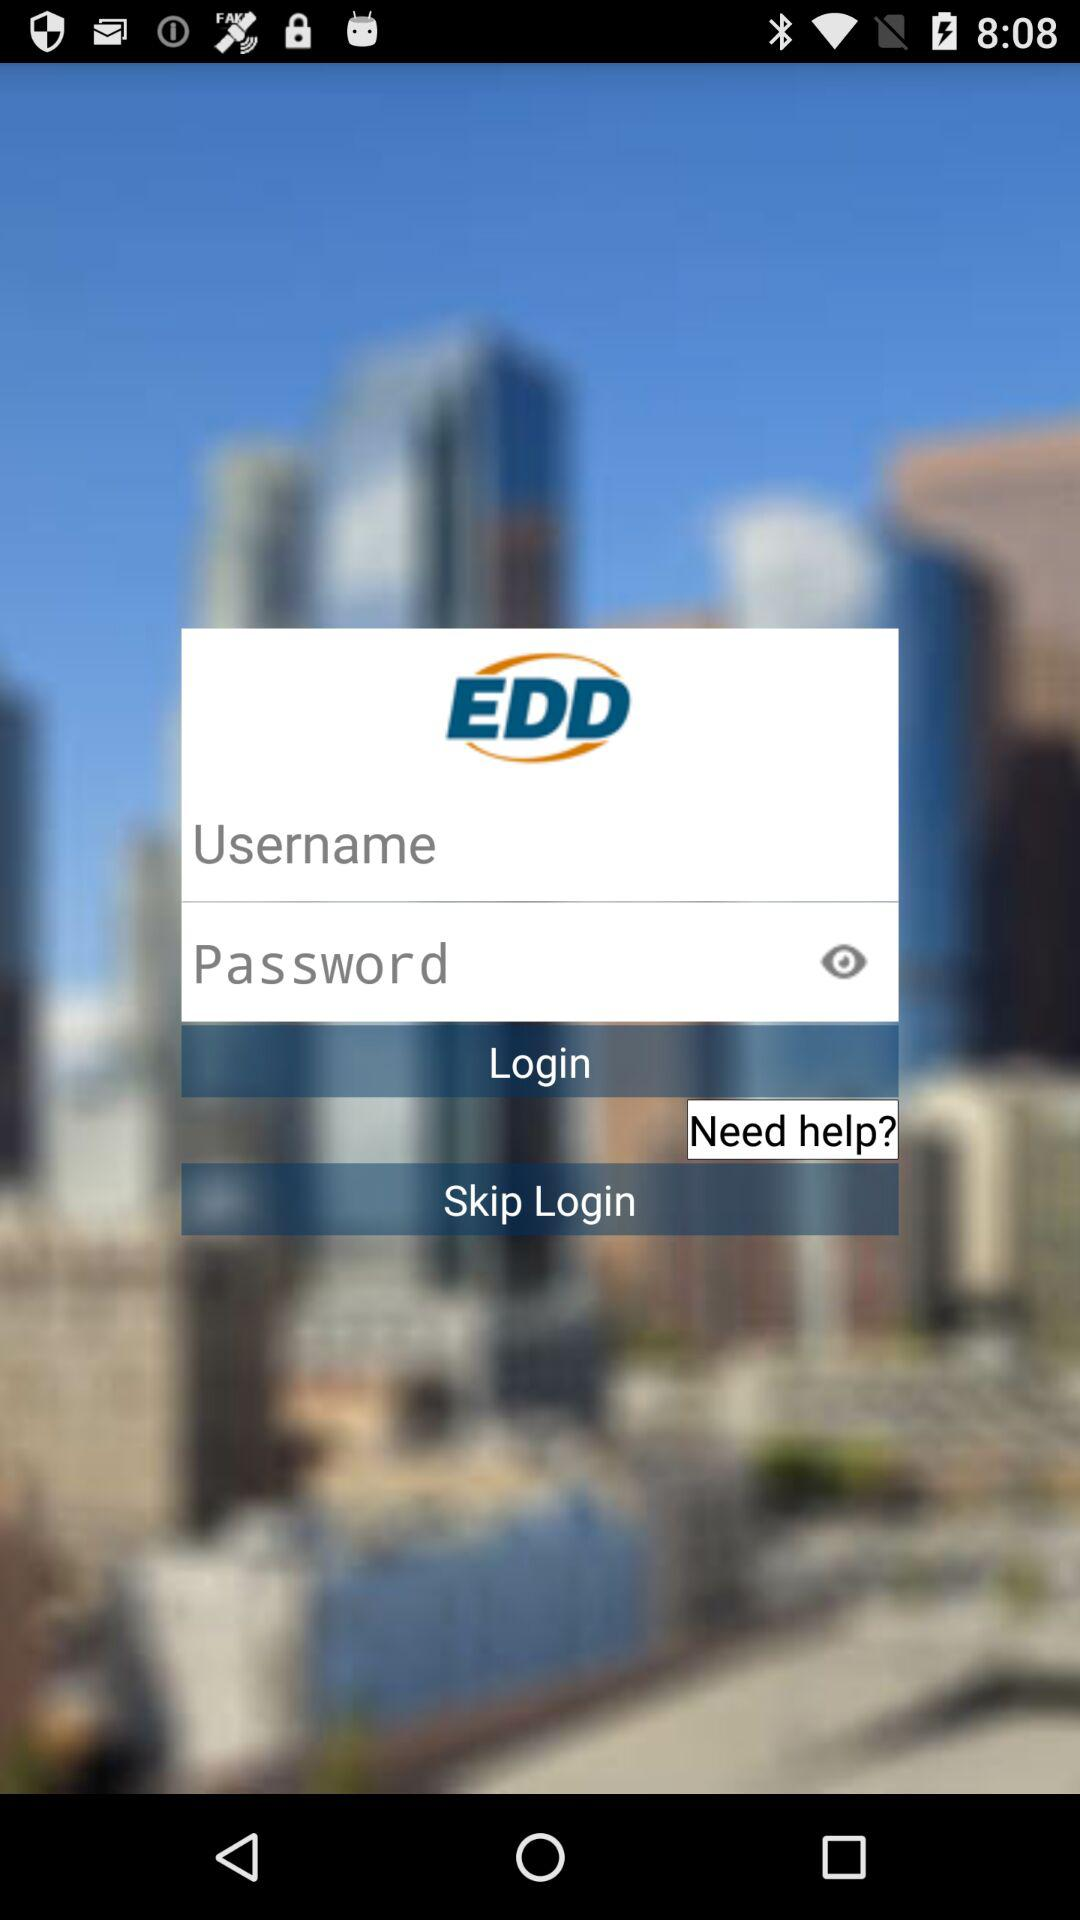What is the app name? The app name is "EDD". 